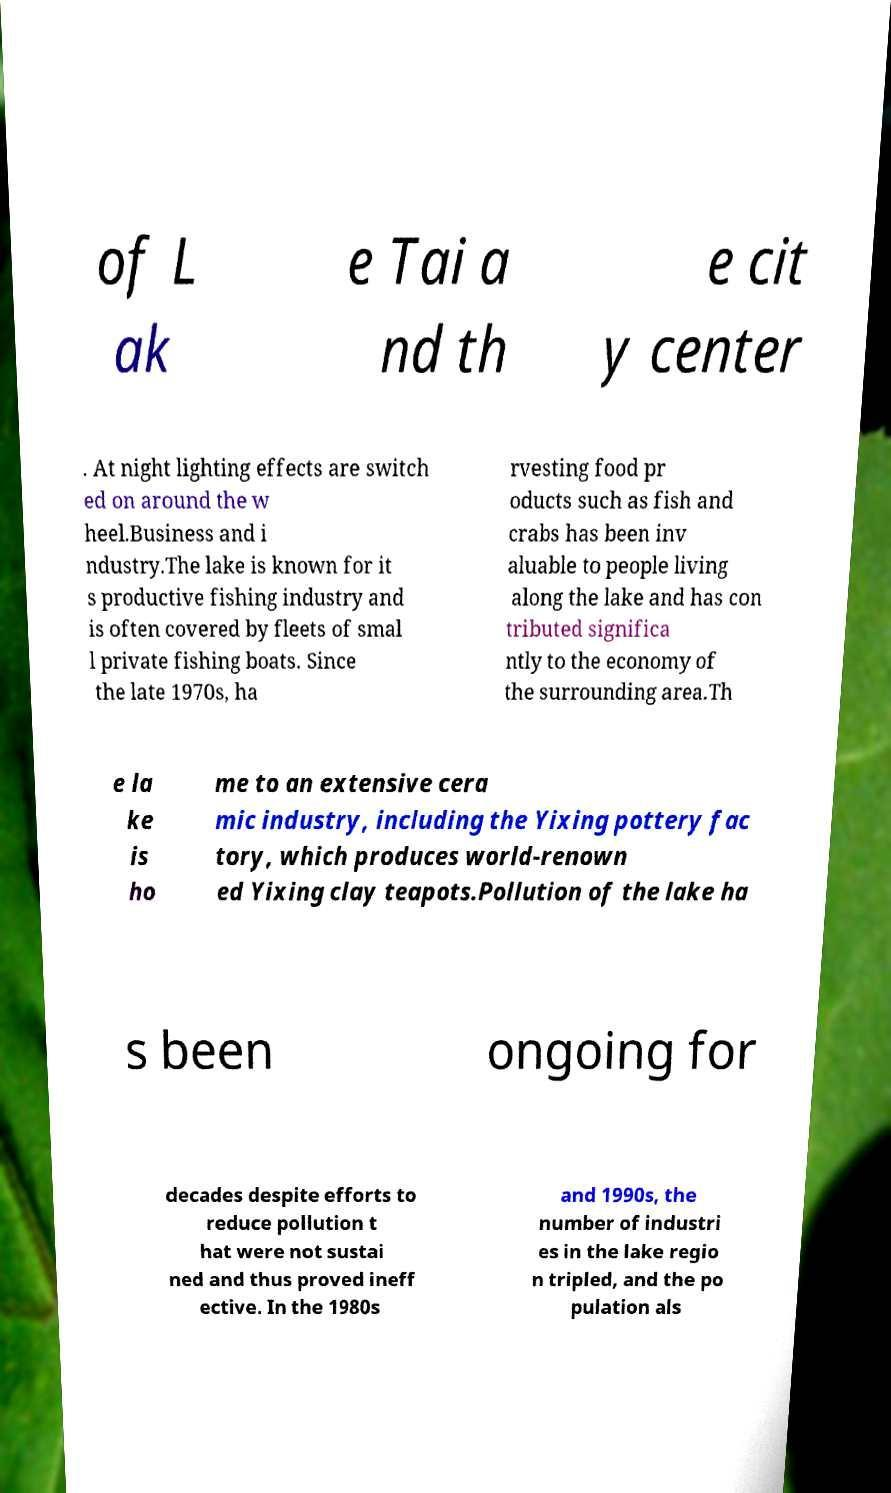For documentation purposes, I need the text within this image transcribed. Could you provide that? of L ak e Tai a nd th e cit y center . At night lighting effects are switch ed on around the w heel.Business and i ndustry.The lake is known for it s productive fishing industry and is often covered by fleets of smal l private fishing boats. Since the late 1970s, ha rvesting food pr oducts such as fish and crabs has been inv aluable to people living along the lake and has con tributed significa ntly to the economy of the surrounding area.Th e la ke is ho me to an extensive cera mic industry, including the Yixing pottery fac tory, which produces world-renown ed Yixing clay teapots.Pollution of the lake ha s been ongoing for decades despite efforts to reduce pollution t hat were not sustai ned and thus proved ineff ective. In the 1980s and 1990s, the number of industri es in the lake regio n tripled, and the po pulation als 